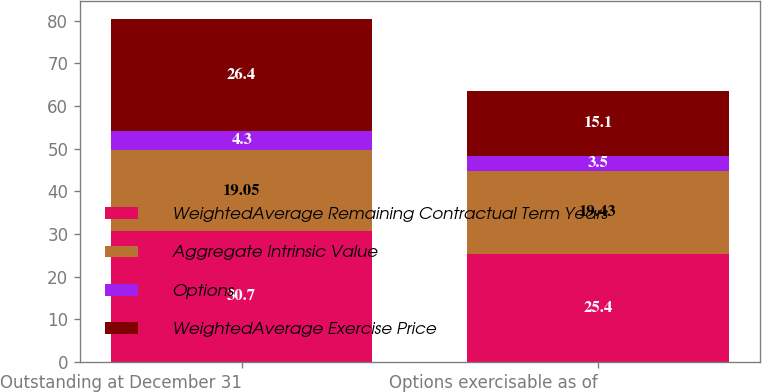Convert chart to OTSL. <chart><loc_0><loc_0><loc_500><loc_500><stacked_bar_chart><ecel><fcel>Outstanding at December 31<fcel>Options exercisable as of<nl><fcel>WeightedAverage Remaining Contractual Term Years<fcel>30.7<fcel>25.4<nl><fcel>Aggregate Intrinsic Value<fcel>19.05<fcel>19.43<nl><fcel>Options<fcel>4.3<fcel>3.5<nl><fcel>WeightedAverage Exercise Price<fcel>26.4<fcel>15.1<nl></chart> 